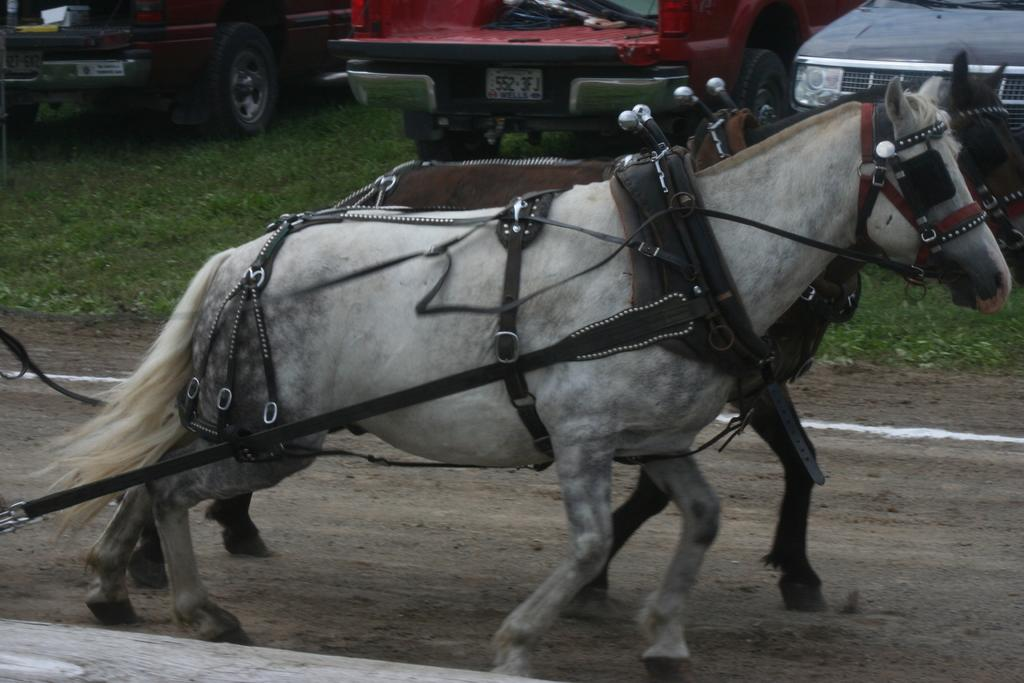How many horses are present in the image? There are two horses in the image. What are the horses doing in the image? The horses are running on the ground. What is attached to the horses? There are cables and ropes on the horses. Can you describe the vehicles in the image? There are three cars parked on the grass in the image. What type of zephyr can be seen flying around the horses in the image? There is no zephyr present in the image; it is a term used to describe a gentle breeze, and there is no mention of wind or breeze in the provided facts. 